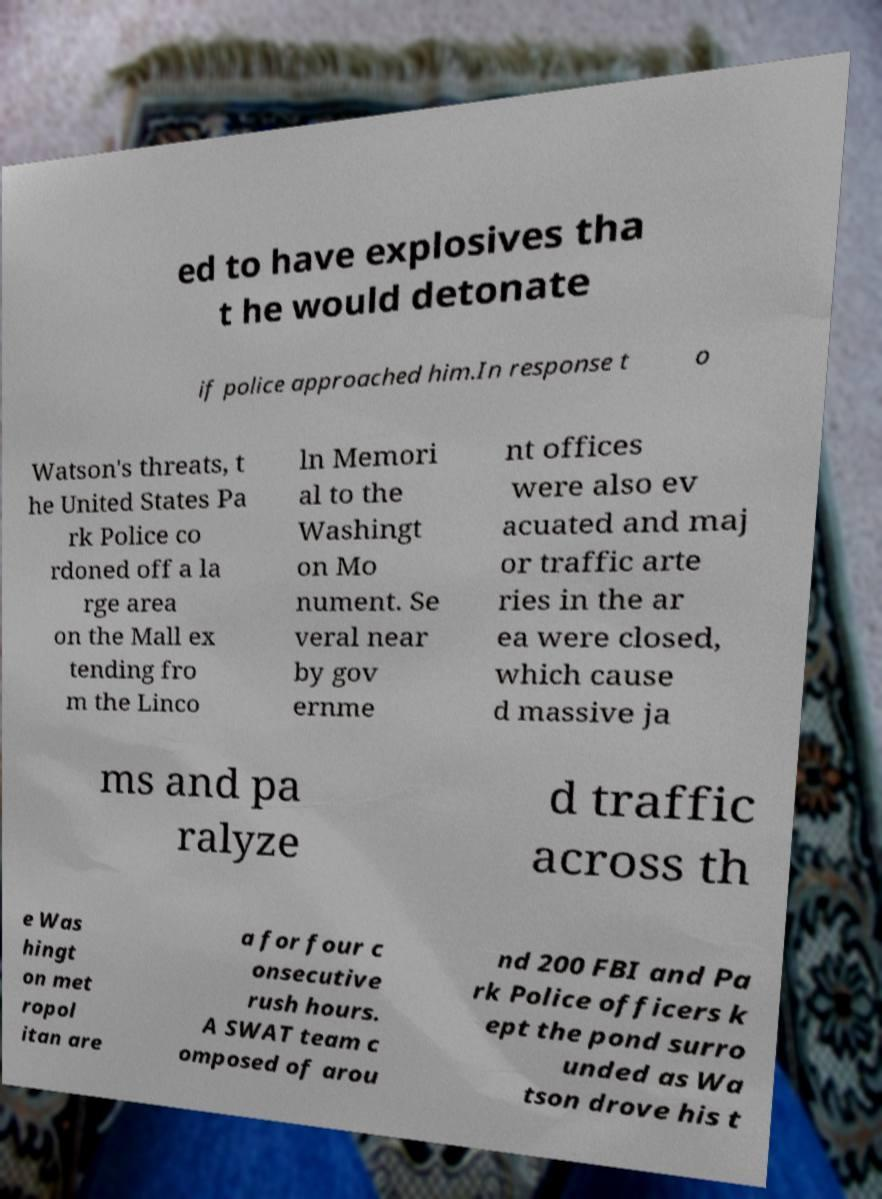For documentation purposes, I need the text within this image transcribed. Could you provide that? ed to have explosives tha t he would detonate if police approached him.In response t o Watson's threats, t he United States Pa rk Police co rdoned off a la rge area on the Mall ex tending fro m the Linco ln Memori al to the Washingt on Mo nument. Se veral near by gov ernme nt offices were also ev acuated and maj or traffic arte ries in the ar ea were closed, which cause d massive ja ms and pa ralyze d traffic across th e Was hingt on met ropol itan are a for four c onsecutive rush hours. A SWAT team c omposed of arou nd 200 FBI and Pa rk Police officers k ept the pond surro unded as Wa tson drove his t 